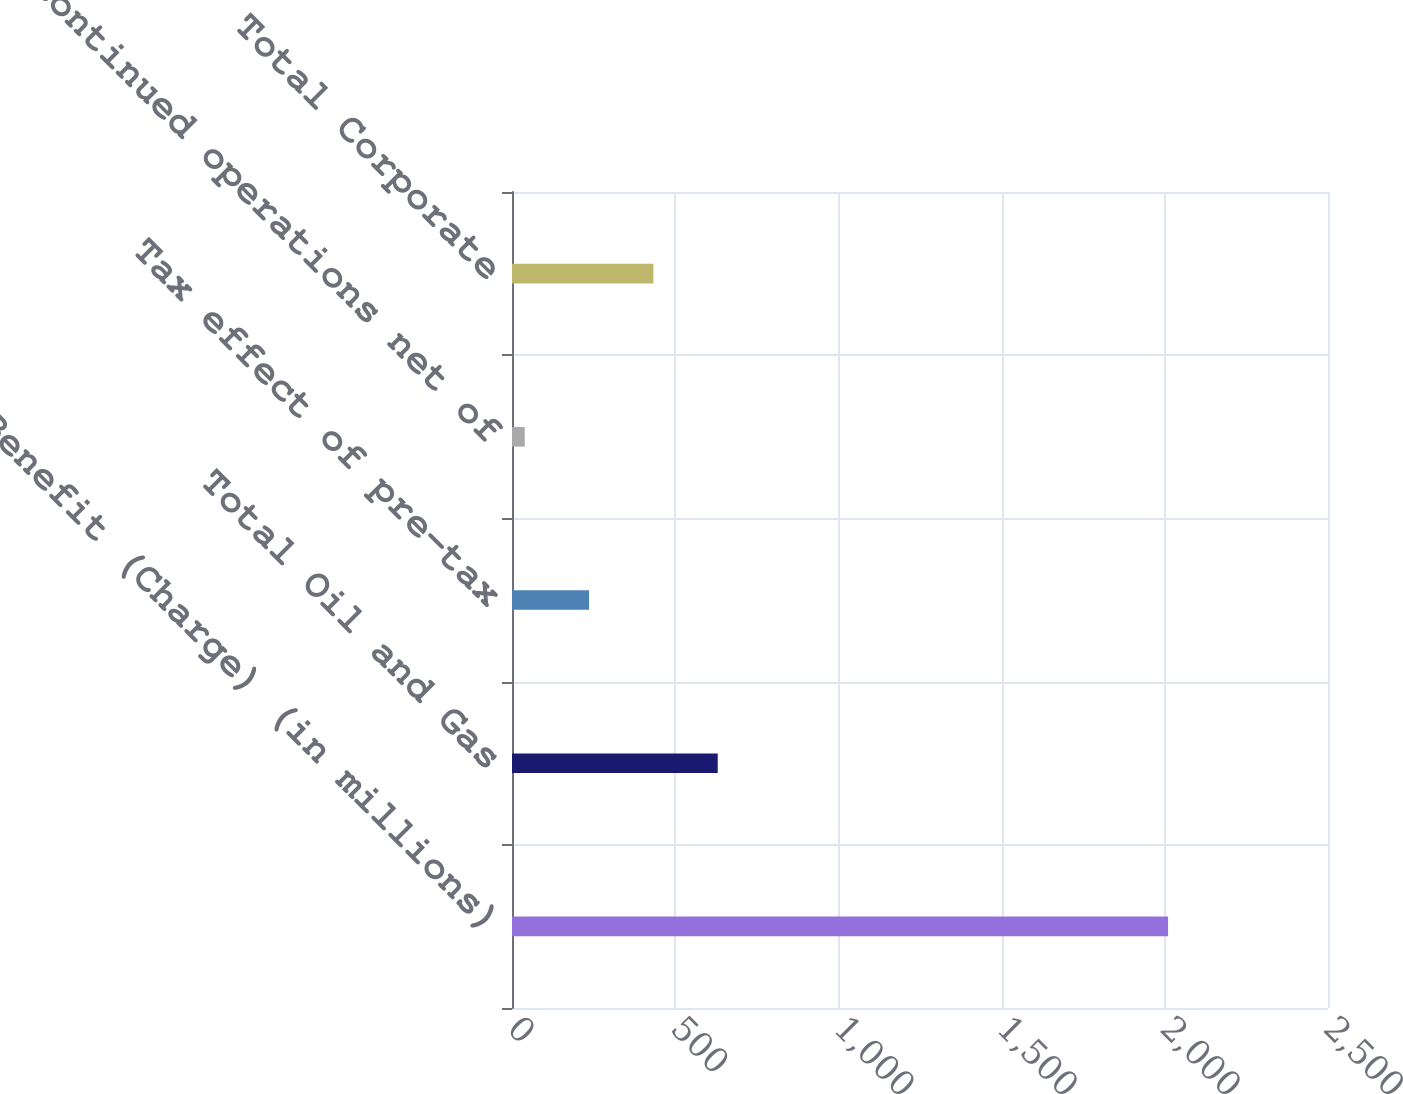<chart> <loc_0><loc_0><loc_500><loc_500><bar_chart><fcel>Benefit (Charge) (in millions)<fcel>Total Oil and Gas<fcel>Tax effect of pre-tax<fcel>Discontinued operations net of<fcel>Total Corporate<nl><fcel>2010<fcel>630.3<fcel>236.1<fcel>39<fcel>433.2<nl></chart> 